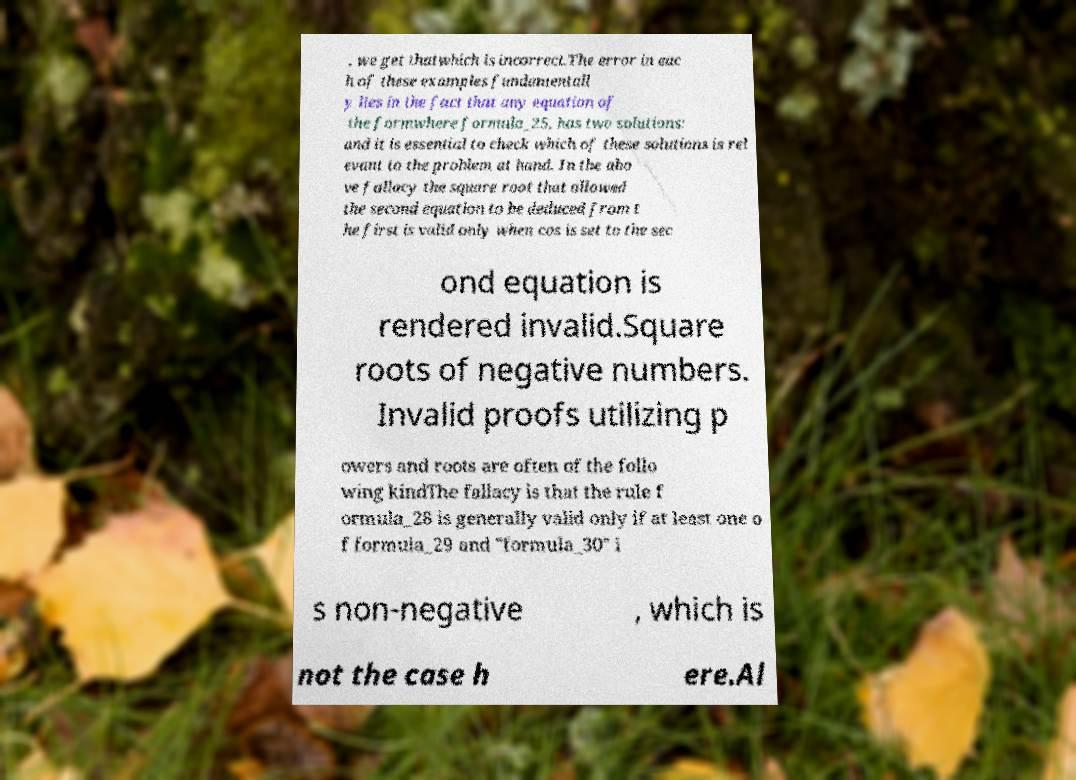For documentation purposes, I need the text within this image transcribed. Could you provide that? , we get thatwhich is incorrect.The error in eac h of these examples fundamentall y lies in the fact that any equation of the formwhere formula_25, has two solutions: and it is essential to check which of these solutions is rel evant to the problem at hand. In the abo ve fallacy the square root that allowed the second equation to be deduced from t he first is valid only when cos is set to the sec ond equation is rendered invalid.Square roots of negative numbers. Invalid proofs utilizing p owers and roots are often of the follo wing kindThe fallacy is that the rule f ormula_28 is generally valid only if at least one o f formula_29 and "formula_30" i s non-negative , which is not the case h ere.Al 